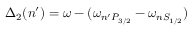<formula> <loc_0><loc_0><loc_500><loc_500>\Delta _ { 2 } ( n ^ { \prime } ) = \omega - ( \omega _ { n ^ { \prime } P _ { 3 / 2 } } - \omega _ { n S _ { 1 / 2 } } )</formula> 